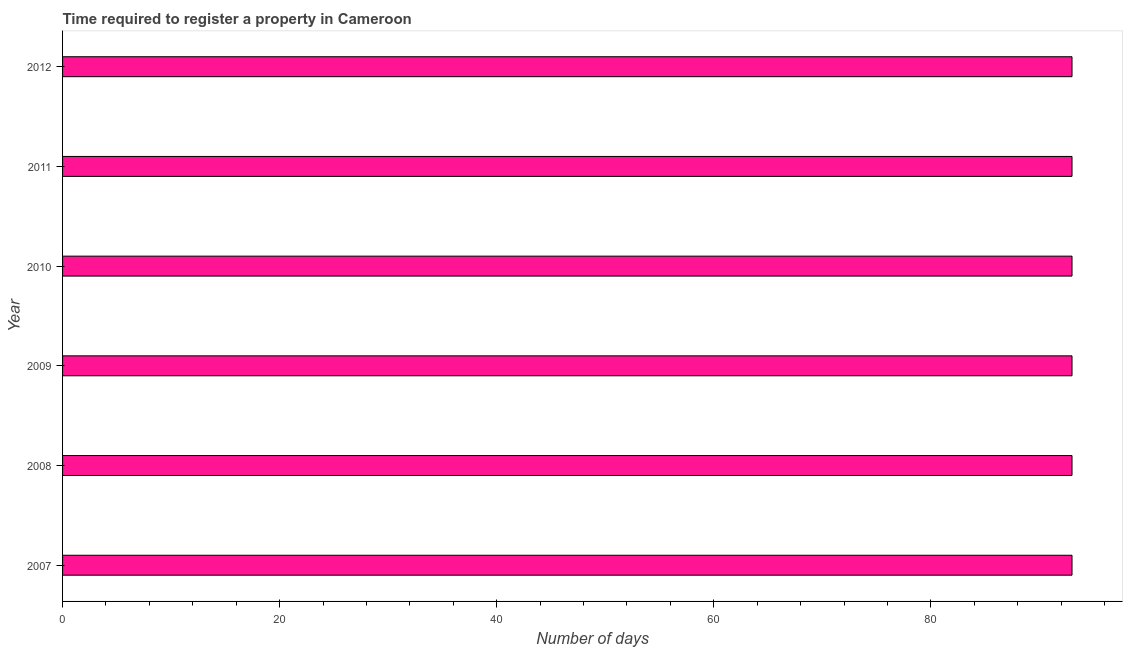Does the graph contain grids?
Offer a terse response. No. What is the title of the graph?
Offer a very short reply. Time required to register a property in Cameroon. What is the label or title of the X-axis?
Provide a succinct answer. Number of days. What is the label or title of the Y-axis?
Your response must be concise. Year. What is the number of days required to register property in 2012?
Give a very brief answer. 93. Across all years, what is the maximum number of days required to register property?
Your response must be concise. 93. Across all years, what is the minimum number of days required to register property?
Provide a succinct answer. 93. In which year was the number of days required to register property maximum?
Your response must be concise. 2007. What is the sum of the number of days required to register property?
Your answer should be very brief. 558. What is the average number of days required to register property per year?
Make the answer very short. 93. What is the median number of days required to register property?
Make the answer very short. 93. Do a majority of the years between 2008 and 2010 (inclusive) have number of days required to register property greater than 68 days?
Ensure brevity in your answer.  Yes. What is the ratio of the number of days required to register property in 2008 to that in 2012?
Your response must be concise. 1. In how many years, is the number of days required to register property greater than the average number of days required to register property taken over all years?
Your response must be concise. 0. How many years are there in the graph?
Make the answer very short. 6. What is the difference between two consecutive major ticks on the X-axis?
Make the answer very short. 20. What is the Number of days of 2007?
Your response must be concise. 93. What is the Number of days in 2008?
Ensure brevity in your answer.  93. What is the Number of days of 2009?
Make the answer very short. 93. What is the Number of days in 2010?
Give a very brief answer. 93. What is the Number of days in 2011?
Provide a succinct answer. 93. What is the Number of days in 2012?
Make the answer very short. 93. What is the difference between the Number of days in 2007 and 2008?
Make the answer very short. 0. What is the difference between the Number of days in 2007 and 2009?
Make the answer very short. 0. What is the difference between the Number of days in 2007 and 2010?
Provide a short and direct response. 0. What is the difference between the Number of days in 2007 and 2011?
Your response must be concise. 0. What is the difference between the Number of days in 2008 and 2011?
Offer a very short reply. 0. What is the difference between the Number of days in 2009 and 2010?
Ensure brevity in your answer.  0. What is the difference between the Number of days in 2009 and 2011?
Ensure brevity in your answer.  0. What is the difference between the Number of days in 2009 and 2012?
Provide a succinct answer. 0. What is the difference between the Number of days in 2010 and 2011?
Your response must be concise. 0. What is the ratio of the Number of days in 2007 to that in 2008?
Ensure brevity in your answer.  1. What is the ratio of the Number of days in 2007 to that in 2011?
Keep it short and to the point. 1. What is the ratio of the Number of days in 2008 to that in 2009?
Make the answer very short. 1. What is the ratio of the Number of days in 2008 to that in 2010?
Offer a terse response. 1. What is the ratio of the Number of days in 2009 to that in 2011?
Make the answer very short. 1. What is the ratio of the Number of days in 2009 to that in 2012?
Your answer should be very brief. 1. 